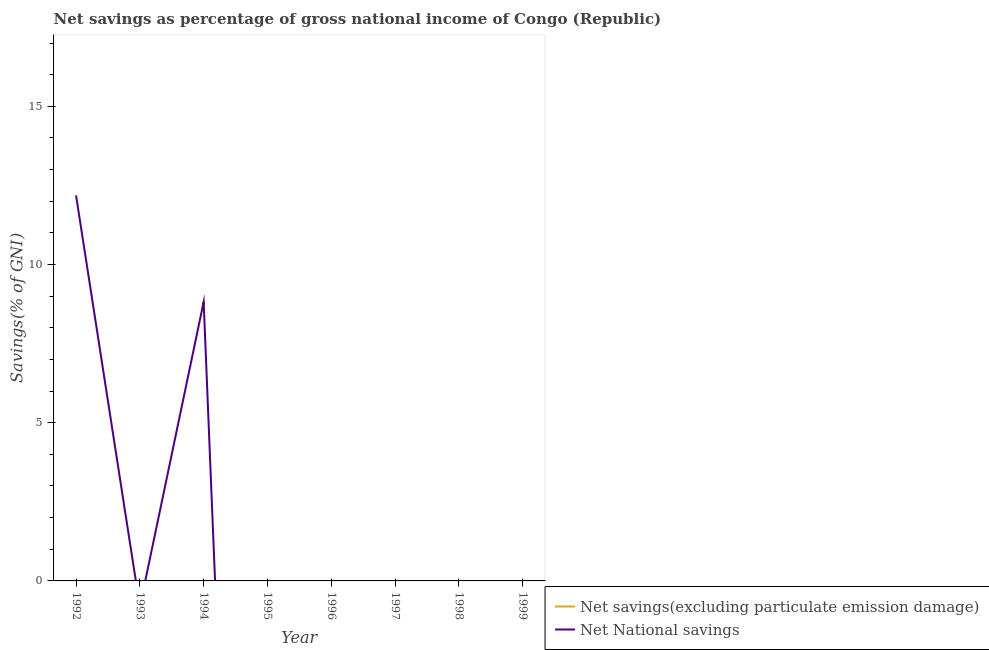Does the line corresponding to net national savings intersect with the line corresponding to net savings(excluding particulate emission damage)?
Provide a short and direct response. No. What is the net savings(excluding particulate emission damage) in 1993?
Make the answer very short. 0. Across all years, what is the maximum net national savings?
Provide a short and direct response. 12.18. Across all years, what is the minimum net savings(excluding particulate emission damage)?
Make the answer very short. 0. What is the total net savings(excluding particulate emission damage) in the graph?
Your answer should be very brief. 0. What is the difference between the net national savings in 1997 and the net savings(excluding particulate emission damage) in 1992?
Offer a very short reply. 0. What is the average net savings(excluding particulate emission damage) per year?
Your answer should be very brief. 0. In how many years, is the net national savings greater than 16 %?
Offer a very short reply. 0. What is the difference between the highest and the lowest net national savings?
Make the answer very short. 12.18. Does the net national savings monotonically increase over the years?
Offer a terse response. No. Is the net savings(excluding particulate emission damage) strictly greater than the net national savings over the years?
Offer a very short reply. No. What is the difference between two consecutive major ticks on the Y-axis?
Offer a very short reply. 5. Does the graph contain any zero values?
Your answer should be very brief. Yes. Where does the legend appear in the graph?
Your answer should be compact. Bottom right. What is the title of the graph?
Offer a very short reply. Net savings as percentage of gross national income of Congo (Republic). Does "Taxes on profits and capital gains" appear as one of the legend labels in the graph?
Your answer should be very brief. No. What is the label or title of the X-axis?
Give a very brief answer. Year. What is the label or title of the Y-axis?
Give a very brief answer. Savings(% of GNI). What is the Savings(% of GNI) of Net savings(excluding particulate emission damage) in 1992?
Keep it short and to the point. 0. What is the Savings(% of GNI) of Net National savings in 1992?
Your answer should be very brief. 12.18. What is the Savings(% of GNI) of Net savings(excluding particulate emission damage) in 1993?
Offer a very short reply. 0. What is the Savings(% of GNI) in Net savings(excluding particulate emission damage) in 1994?
Ensure brevity in your answer.  0. What is the Savings(% of GNI) in Net National savings in 1994?
Offer a very short reply. 8.82. What is the Savings(% of GNI) in Net National savings in 1995?
Make the answer very short. 0. What is the Savings(% of GNI) of Net savings(excluding particulate emission damage) in 1996?
Give a very brief answer. 0. What is the Savings(% of GNI) in Net National savings in 1996?
Provide a short and direct response. 0. What is the Savings(% of GNI) in Net National savings in 1997?
Your response must be concise. 0. What is the Savings(% of GNI) of Net National savings in 1998?
Offer a terse response. 0. What is the Savings(% of GNI) in Net National savings in 1999?
Provide a succinct answer. 0. Across all years, what is the maximum Savings(% of GNI) of Net National savings?
Ensure brevity in your answer.  12.18. What is the total Savings(% of GNI) of Net National savings in the graph?
Give a very brief answer. 21. What is the difference between the Savings(% of GNI) of Net National savings in 1992 and that in 1994?
Keep it short and to the point. 3.37. What is the average Savings(% of GNI) of Net savings(excluding particulate emission damage) per year?
Give a very brief answer. 0. What is the average Savings(% of GNI) of Net National savings per year?
Offer a very short reply. 2.63. What is the ratio of the Savings(% of GNI) of Net National savings in 1992 to that in 1994?
Your answer should be very brief. 1.38. What is the difference between the highest and the lowest Savings(% of GNI) in Net National savings?
Offer a terse response. 12.18. 